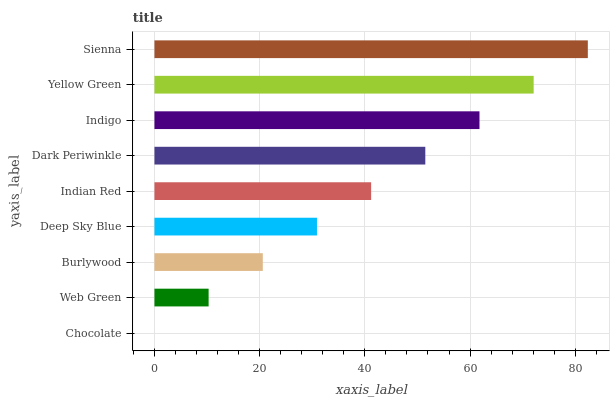Is Chocolate the minimum?
Answer yes or no. Yes. Is Sienna the maximum?
Answer yes or no. Yes. Is Web Green the minimum?
Answer yes or no. No. Is Web Green the maximum?
Answer yes or no. No. Is Web Green greater than Chocolate?
Answer yes or no. Yes. Is Chocolate less than Web Green?
Answer yes or no. Yes. Is Chocolate greater than Web Green?
Answer yes or no. No. Is Web Green less than Chocolate?
Answer yes or no. No. Is Indian Red the high median?
Answer yes or no. Yes. Is Indian Red the low median?
Answer yes or no. Yes. Is Deep Sky Blue the high median?
Answer yes or no. No. Is Yellow Green the low median?
Answer yes or no. No. 